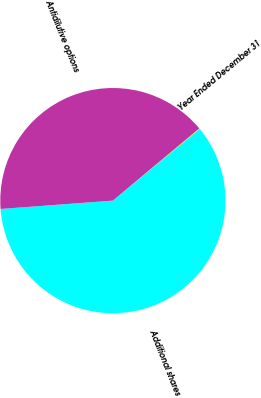<chart> <loc_0><loc_0><loc_500><loc_500><pie_chart><fcel>Year Ended December 31<fcel>Additional shares<fcel>Antidilutive options<nl><fcel>0.12%<fcel>59.79%<fcel>40.1%<nl></chart> 